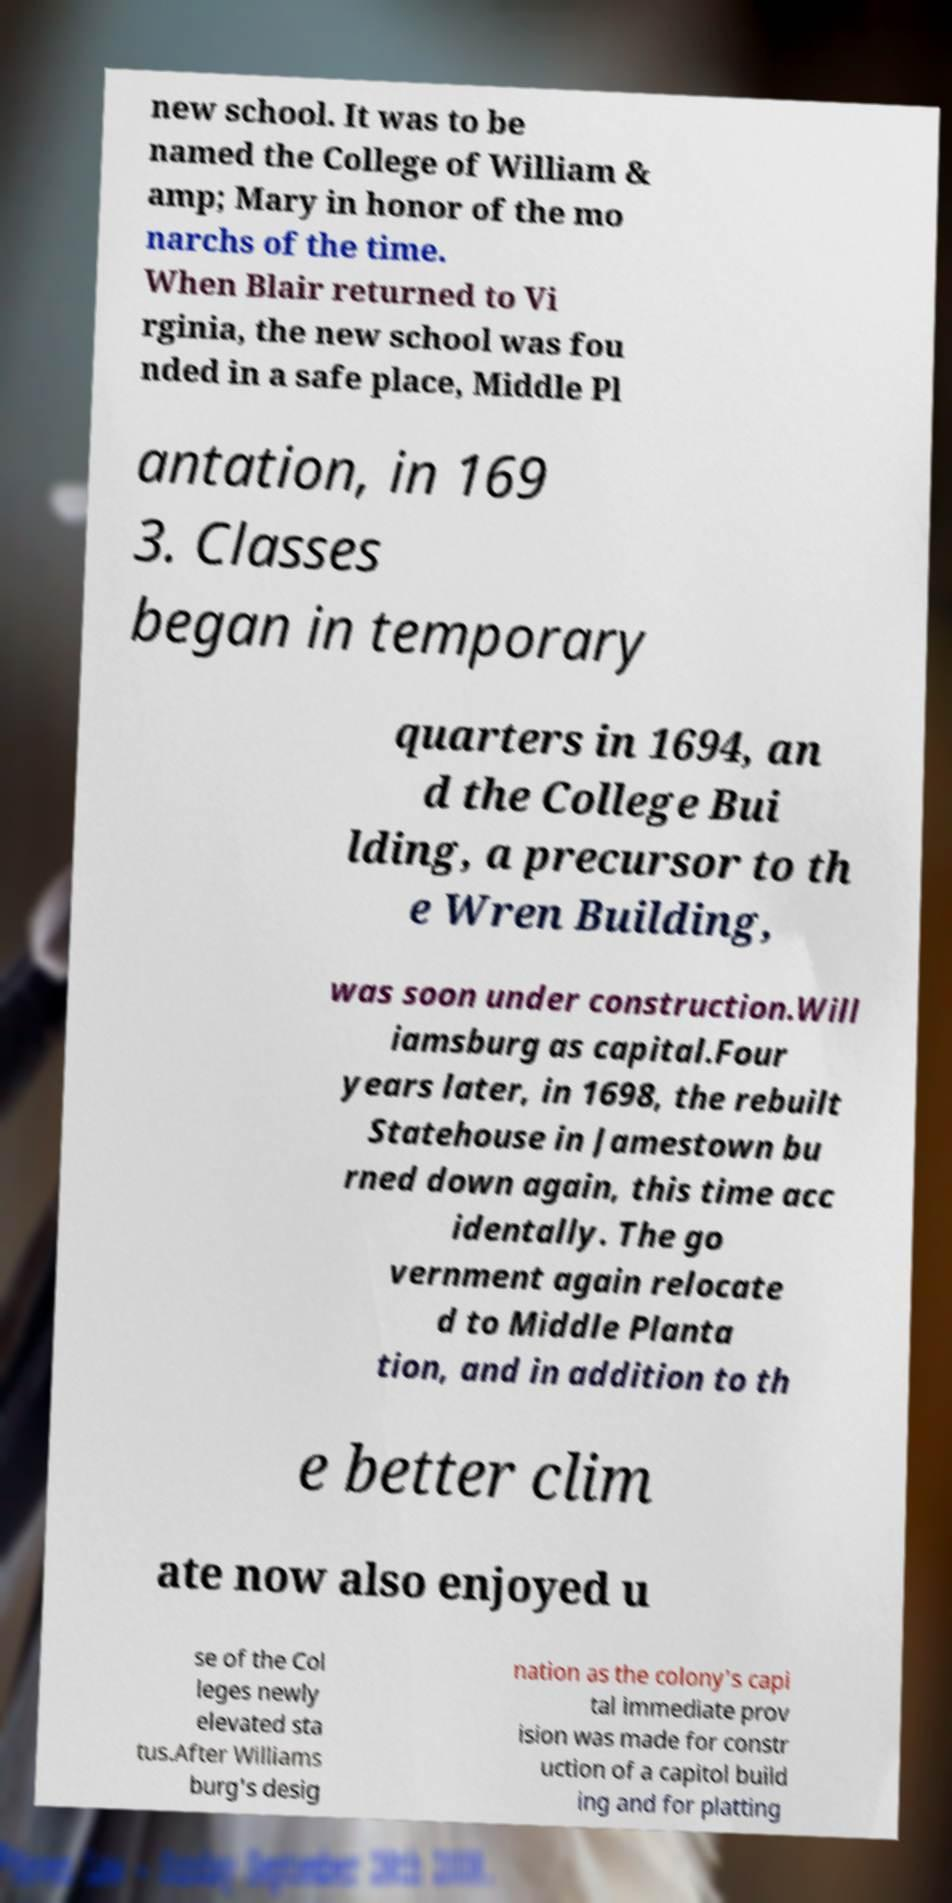Could you assist in decoding the text presented in this image and type it out clearly? new school. It was to be named the College of William & amp; Mary in honor of the mo narchs of the time. When Blair returned to Vi rginia, the new school was fou nded in a safe place, Middle Pl antation, in 169 3. Classes began in temporary quarters in 1694, an d the College Bui lding, a precursor to th e Wren Building, was soon under construction.Will iamsburg as capital.Four years later, in 1698, the rebuilt Statehouse in Jamestown bu rned down again, this time acc identally. The go vernment again relocate d to Middle Planta tion, and in addition to th e better clim ate now also enjoyed u se of the Col leges newly elevated sta tus.After Williams burg's desig nation as the colony's capi tal immediate prov ision was made for constr uction of a capitol build ing and for platting 